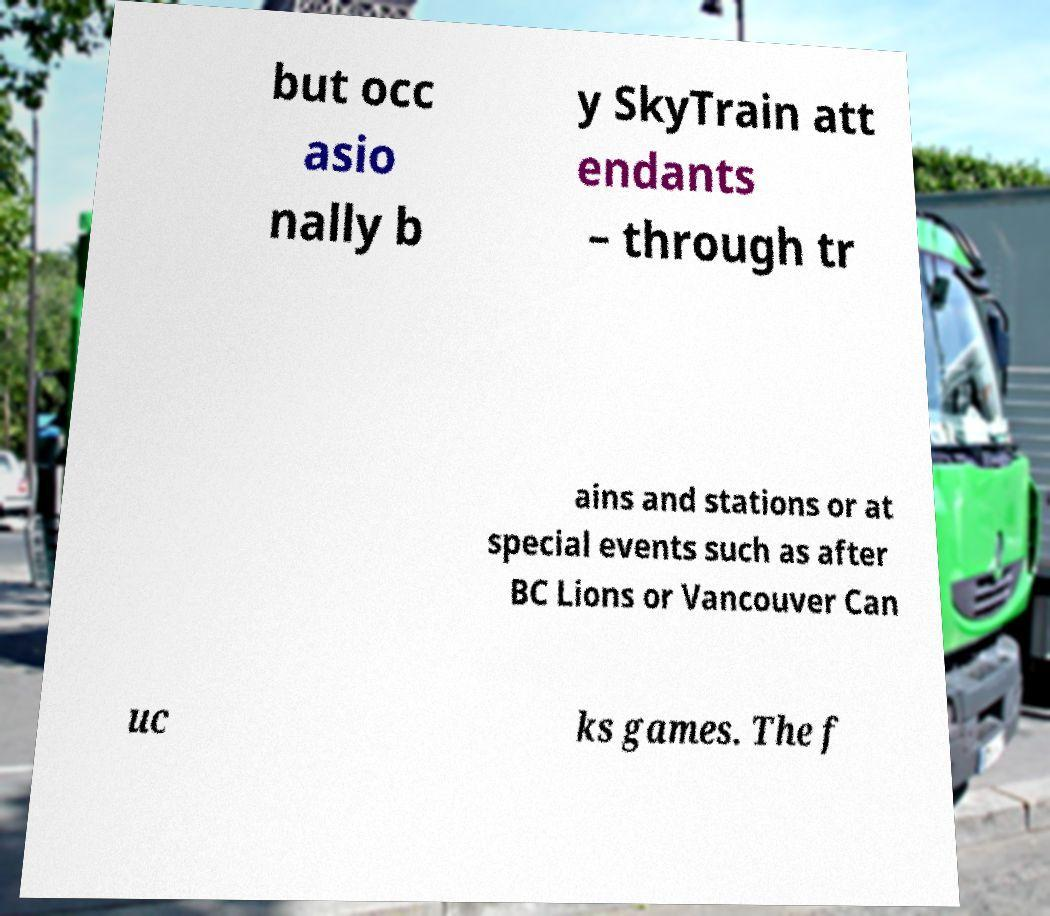Could you assist in decoding the text presented in this image and type it out clearly? but occ asio nally b y SkyTrain att endants – through tr ains and stations or at special events such as after BC Lions or Vancouver Can uc ks games. The f 